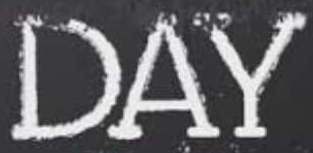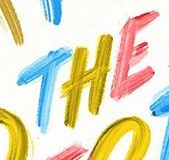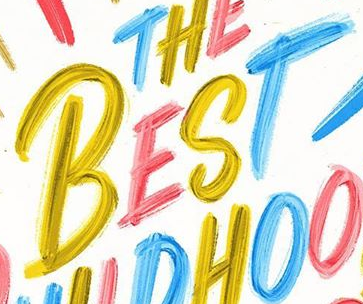Read the text content from these images in order, separated by a semicolon. DAY; THE; BEST 